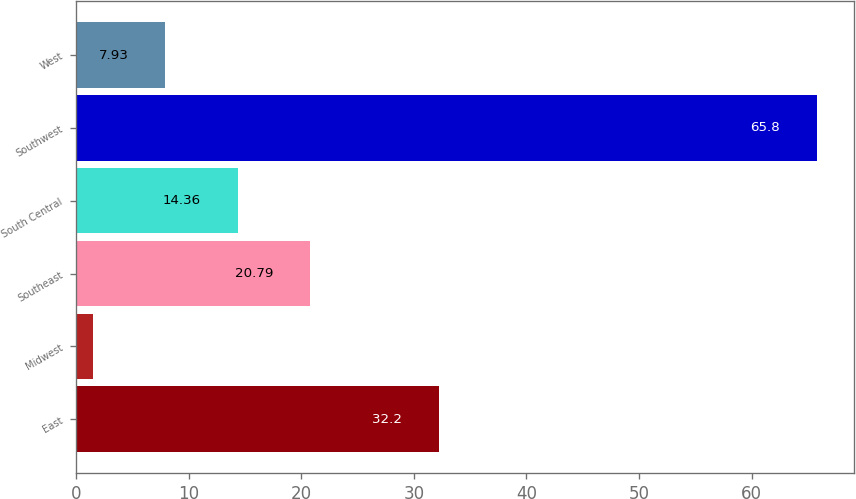Convert chart. <chart><loc_0><loc_0><loc_500><loc_500><bar_chart><fcel>East<fcel>Midwest<fcel>Southeast<fcel>South Central<fcel>Southwest<fcel>West<nl><fcel>32.2<fcel>1.5<fcel>20.79<fcel>14.36<fcel>65.8<fcel>7.93<nl></chart> 